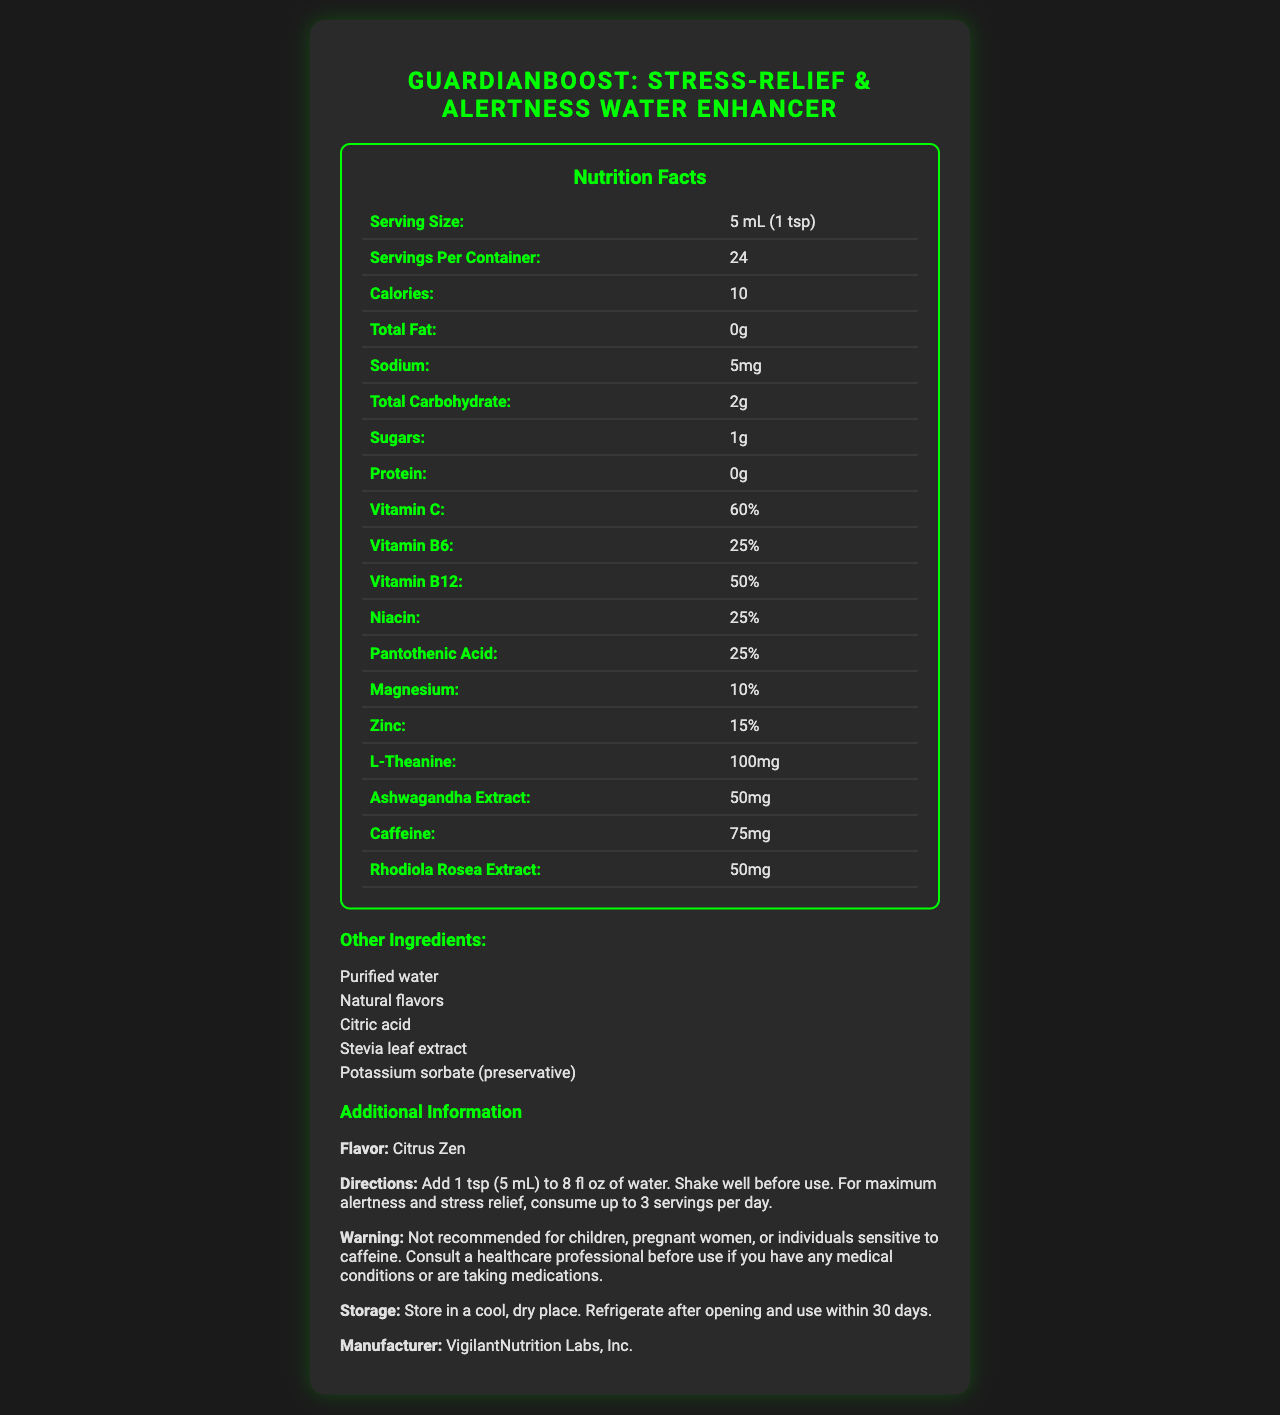what is the name of the product? The product name is prominently displayed at the top of the document.
Answer: GuardianBoost: Stress-Relief & Alertness Water Enhancer what is the serving size? The serving size is listed in the Nutrition Facts section of the document.
Answer: 5 mL (1 tsp) how many calories are in one serving? The number of calories per serving is shown in the Nutrition Facts section.
Answer: 10 how much caffeine is in one serving? The amount of caffeine per serving is listed in the Nutrition Facts section.
Answer: 75 mg what is the primary flavor of this product? The flavor of the product is mentioned under the "Additional Information" section.
Answer: Citrus Zen how many servings are there per container? The number of servings per container is listed in the Nutrition Facts section.
Answer: 24 who is the target audience for this product? The target audience is mentioned in the product description.
Answer: Security professionals, bodyguards, and individuals in high-stress occupations requiring sustained alertness which vitamin is present in the highest percentage per serving: A. Vitamin C B. Vitamin B6 C. Vitamin B12 Vitamin C is present at 60% per serving, which is the highest percentage among the listed vitamins.
Answer: A. Vitamin C how should the product be stored? A. In a warm place B. In a cool, dry place C. No specific storage instructions The storage instructions mention storing the product in a cool, dry place.
Answer: B. In a cool, dry place what is the recommended daily maximum number of servings? A. 1 serving B. 2 servings C. 3 servings The directions state to consume up to 3 servings per day for maximum alertness and stress relief.
Answer: C. 3 servings is this product suitable for children? The warning clearly states that it is not recommended for children.
Answer: No what are some of the key ingredients promoting stress relief in this product? These ingredients are listed in the Nutrition Facts section and are known for their stress relief properties.
Answer: L-Theanine, Ashwagandha Extract, Rhodiola Rosea Extract is caffeine content mentioned in the ingredients list? The amount of caffeine (75 mg) is listed in the Nutrition Facts section.
Answer: Yes can you determine the price of the product from this document? The document does not provide any pricing information.
Answer: Not enough information summarize the main benefits of this product These benefits are listed in the product benefits section.
Answer: Supports mental alertness, promotes stress relief, enhances focus and concentration, boosts immune system, aids in hydration describe the entire document The description encompasses all major sections and information provided in the document.
Answer: This document provides detailed nutritional information and benefits of the "GuardianBoost: Stress-Relief & Alertness Water Enhancer". It outlines the ingredients, serving size, calories, and various vitamins and minerals. It also includes directions for use, storage instructions, warnings, and its target audience. The document highlights the product's benefits and key features such as being sugar-free, rapid absorption, and travel-friendly packaging. The product is flavored "Citrus Zen" and is manufactured by VigilantNutrition Labs, Inc. 